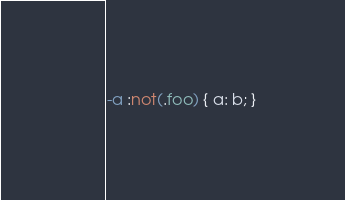Convert code to text. <code><loc_0><loc_0><loc_500><loc_500><_CSS_>-a :not(.foo) { a: b; }
</code> 